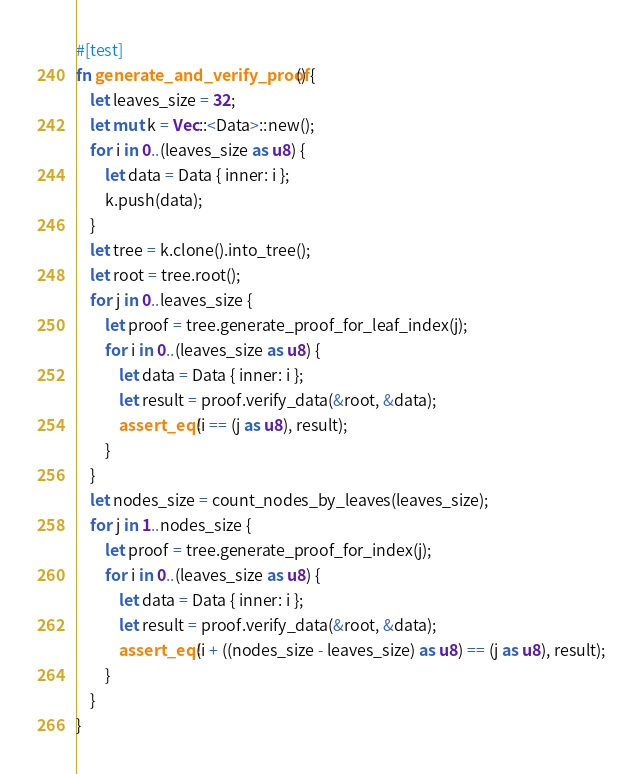Convert code to text. <code><loc_0><loc_0><loc_500><loc_500><_Rust_>#[test]
fn generate_and_verify_proof() {
    let leaves_size = 32;
    let mut k = Vec::<Data>::new();
    for i in 0..(leaves_size as u8) {
        let data = Data { inner: i };
        k.push(data);
    }
    let tree = k.clone().into_tree();
    let root = tree.root();
    for j in 0..leaves_size {
        let proof = tree.generate_proof_for_leaf_index(j);
        for i in 0..(leaves_size as u8) {
            let data = Data { inner: i };
            let result = proof.verify_data(&root, &data);
            assert_eq!(i == (j as u8), result);
        }
    }
    let nodes_size = count_nodes_by_leaves(leaves_size);
    for j in 1..nodes_size {
        let proof = tree.generate_proof_for_index(j);
        for i in 0..(leaves_size as u8) {
            let data = Data { inner: i };
            let result = proof.verify_data(&root, &data);
            assert_eq!(i + ((nodes_size - leaves_size) as u8) == (j as u8), result);
        }
    }
}
</code> 